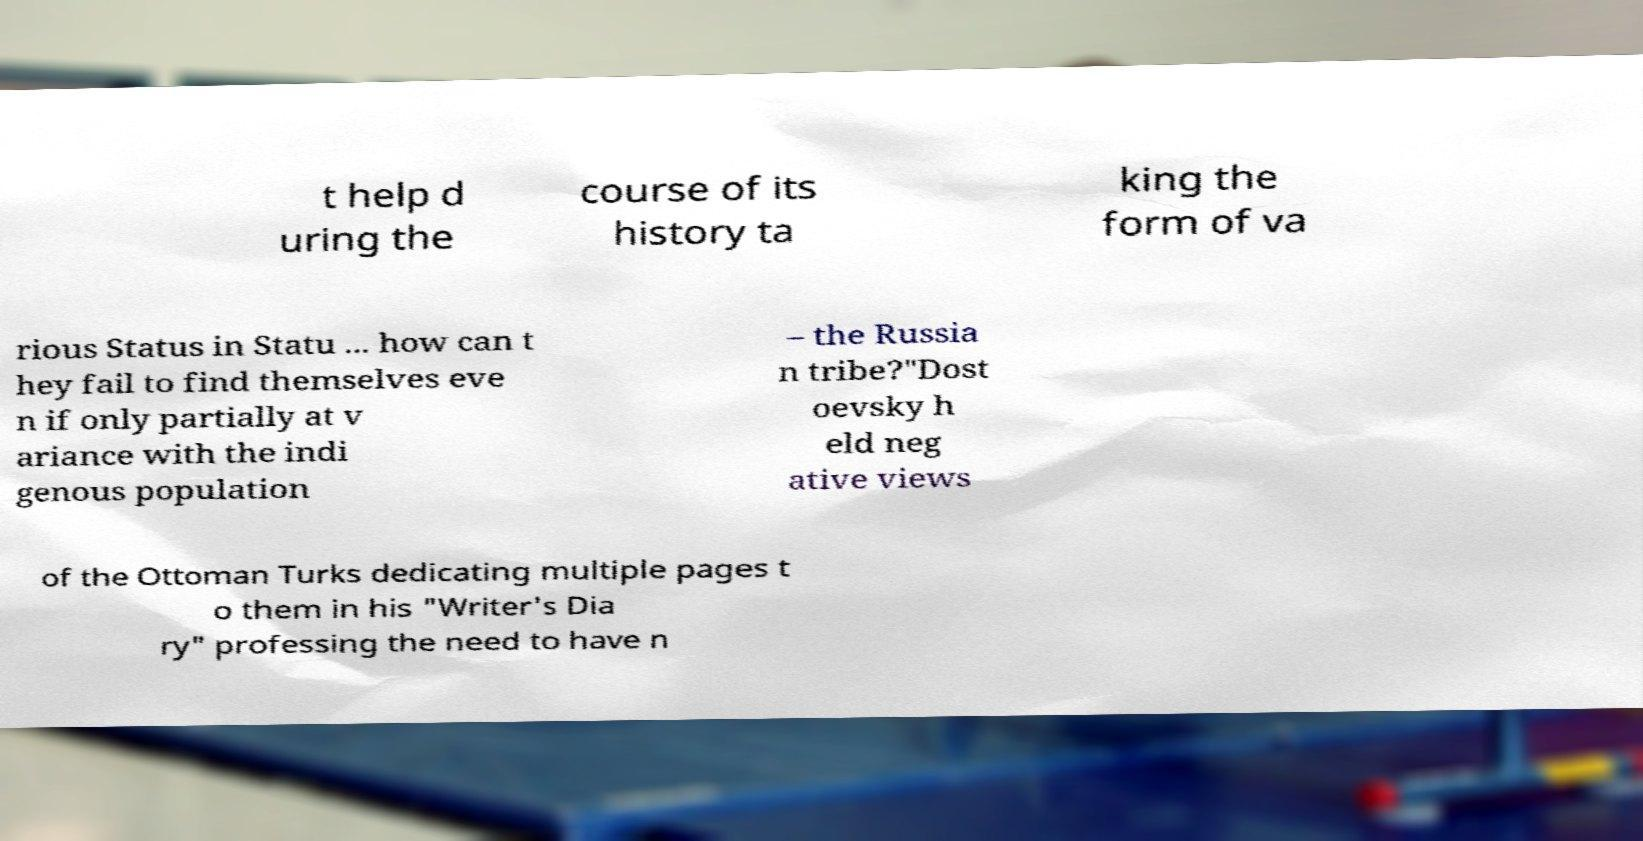Could you extract and type out the text from this image? t help d uring the course of its history ta king the form of va rious Status in Statu ... how can t hey fail to find themselves eve n if only partially at v ariance with the indi genous population – the Russia n tribe?"Dost oevsky h eld neg ative views of the Ottoman Turks dedicating multiple pages t o them in his "Writer's Dia ry" professing the need to have n 